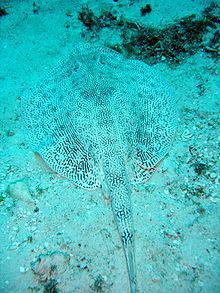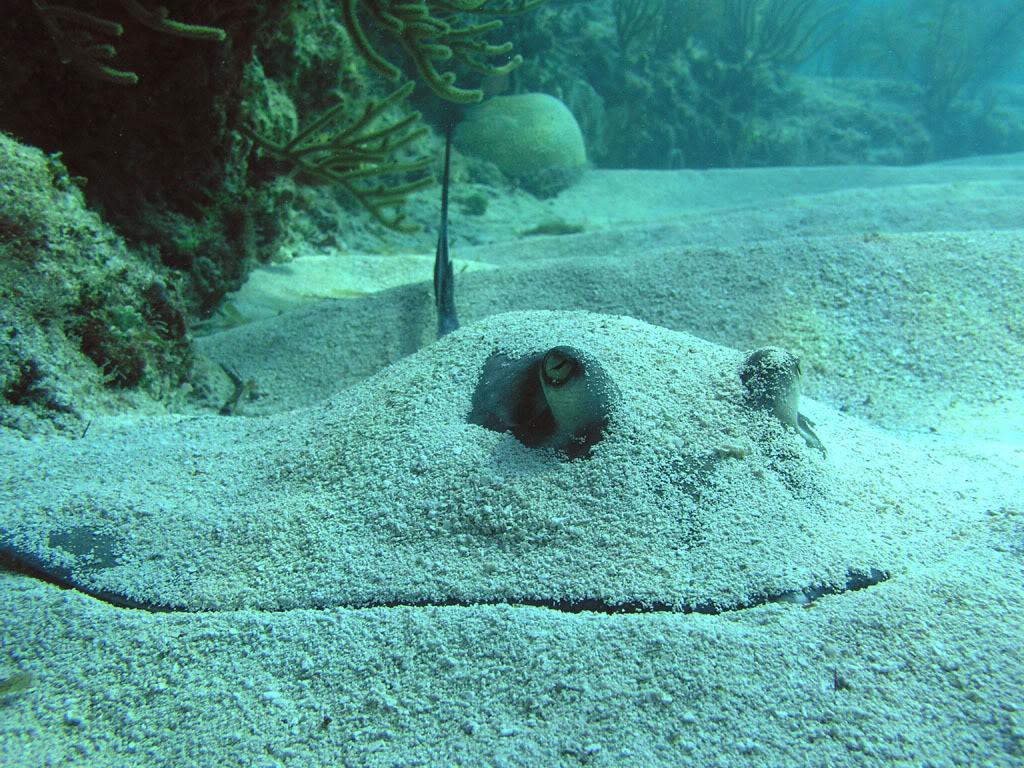The first image is the image on the left, the second image is the image on the right. Analyze the images presented: Is the assertion "The left and right image contains the same number of  stingrays pointed the same direction." valid? Answer yes or no. No. The first image is the image on the left, the second image is the image on the right. For the images displayed, is the sentence "The stingray in the left image is nearly covered in sand." factually correct? Answer yes or no. No. 